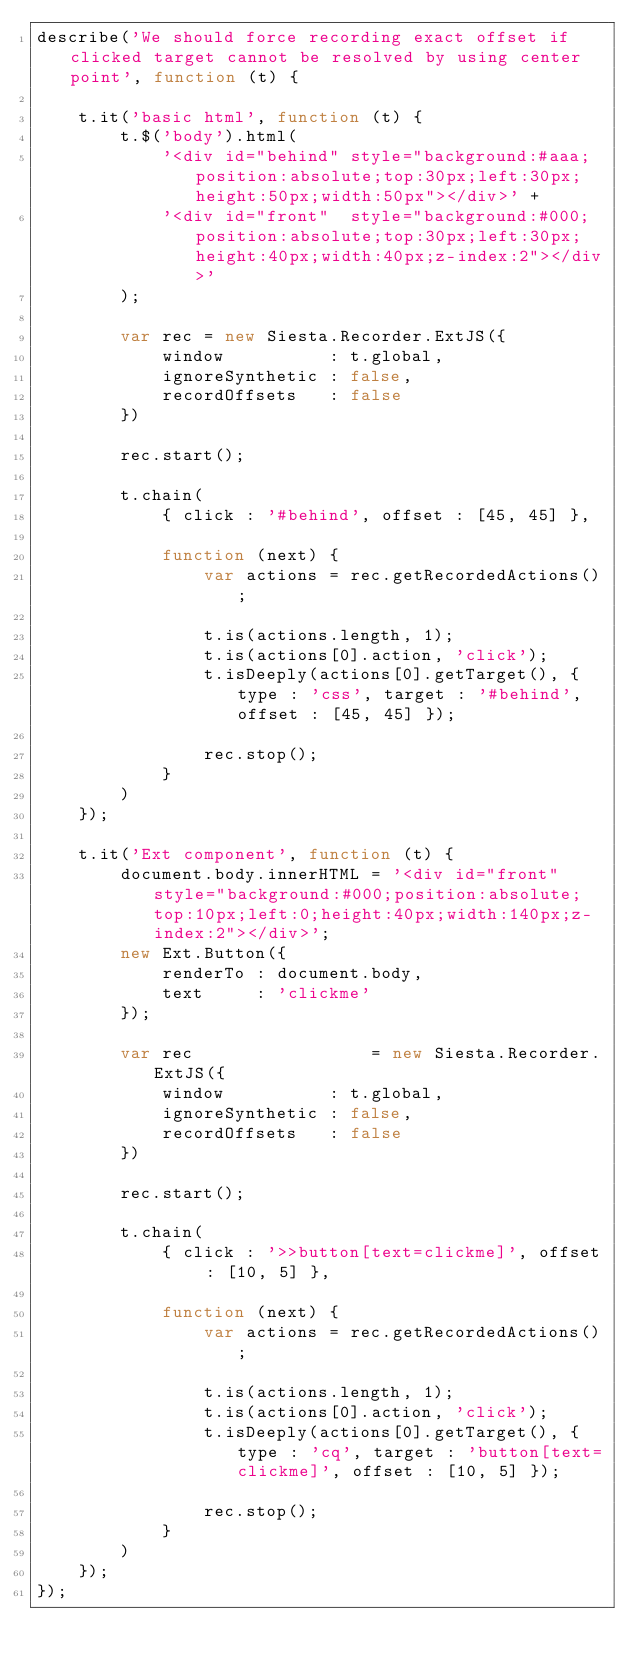Convert code to text. <code><loc_0><loc_0><loc_500><loc_500><_JavaScript_>describe('We should force recording exact offset if clicked target cannot be resolved by using center point', function (t) {

    t.it('basic html', function (t) {
        t.$('body').html(
            '<div id="behind" style="background:#aaa;position:absolute;top:30px;left:30px;height:50px;width:50px"></div>' +
            '<div id="front"  style="background:#000;position:absolute;top:30px;left:30px;height:40px;width:40px;z-index:2"></div>'
        );

        var rec = new Siesta.Recorder.ExtJS({
            window          : t.global,
            ignoreSynthetic : false,
            recordOffsets   : false
        })

        rec.start();

        t.chain(
            { click : '#behind', offset : [45, 45] },

            function (next) {
                var actions = rec.getRecordedActions();

                t.is(actions.length, 1);
                t.is(actions[0].action, 'click');
                t.isDeeply(actions[0].getTarget(), { type : 'css', target : '#behind', offset : [45, 45] });

                rec.stop();
            }
        )
    });

    t.it('Ext component', function (t) {
        document.body.innerHTML = '<div id="front" style="background:#000;position:absolute;top:10px;left:0;height:40px;width:140px;z-index:2"></div>';
        new Ext.Button({
            renderTo : document.body,
            text     : 'clickme'
        });

        var rec                 = new Siesta.Recorder.ExtJS({
            window          : t.global,
            ignoreSynthetic : false,
            recordOffsets   : false
        })

        rec.start();

        t.chain(
            { click : '>>button[text=clickme]', offset : [10, 5] },

            function (next) {
                var actions = rec.getRecordedActions();

                t.is(actions.length, 1);
                t.is(actions[0].action, 'click');
                t.isDeeply(actions[0].getTarget(), { type : 'cq', target : 'button[text=clickme]', offset : [10, 5] });

                rec.stop();
            }
        )
    });
});
</code> 